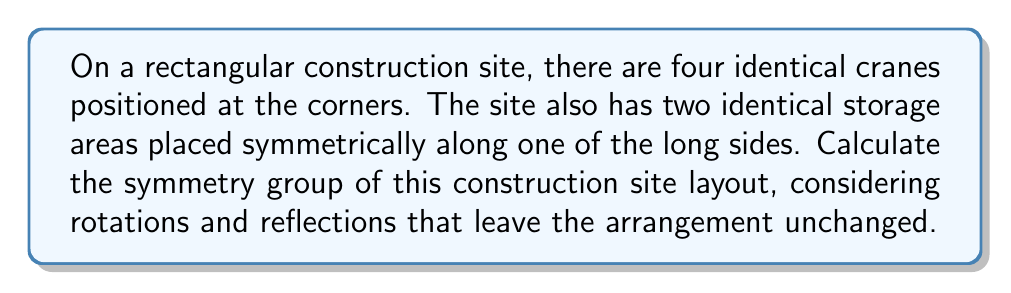Show me your answer to this math problem. Let's approach this step-by-step:

1) First, we need to identify the symmetries of the layout:

   a) Rotations: The site has 180° rotational symmetry (2-fold rotation).
   b) Reflections: There are two lines of reflection - one across the short axis and one across the long axis.

2) These symmetries form a group. Let's denote:
   - $e$ as the identity transformation
   - $r$ as the 180° rotation
   - $h$ as the reflection across the horizontal (short) axis
   - $v$ as the reflection across the vertical (long) axis

3) We can create a multiplication table for these elements:

   $$
   \begin{array}{c|cccc}
     & e & r & h & v \\
   \hline
   e & e & r & h & v \\
   r & r & e & v & h \\
   h & h & v & e & r \\
   v & v & h & r & e
   \end{array}
   $$

4) This group structure is isomorphic to the Klein four-group, also known as $V_4$ or $C_2 \times C_2$.

5) In terms of symmetry groups, this is equivalent to $D_2$, the dihedral group of order 4.

6) The order of this group (number of elements) is 4.

7) In cycle notation, these symmetries can be represented as:
   - $e = (1)(2)(3)(4)$
   - $r = (1,3)(2,4)$
   - $h = (1,2)(3,4)$
   - $v = (1,4)(2,3)$

Where 1, 2, 3, 4 represent the four corners of the site.
Answer: $D_2$ or $V_4$ 